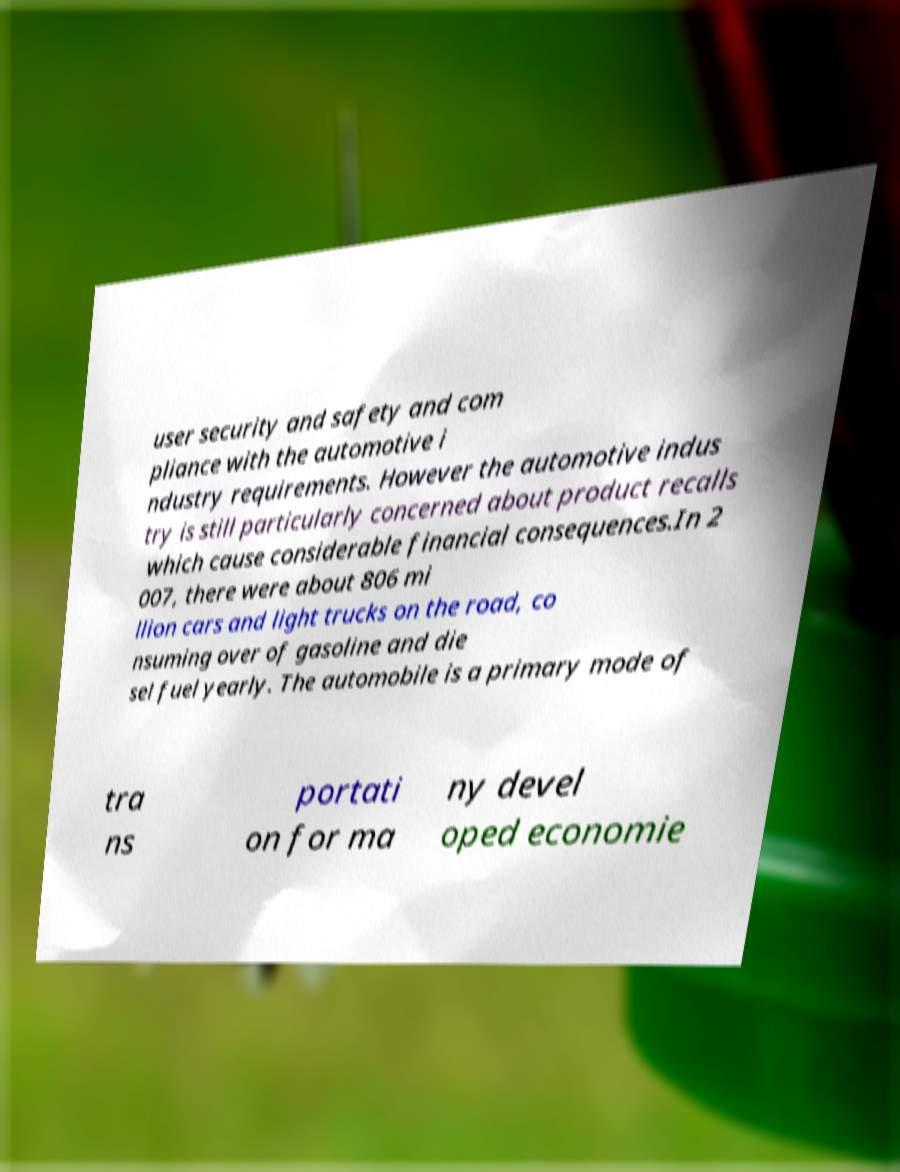Please identify and transcribe the text found in this image. user security and safety and com pliance with the automotive i ndustry requirements. However the automotive indus try is still particularly concerned about product recalls which cause considerable financial consequences.In 2 007, there were about 806 mi llion cars and light trucks on the road, co nsuming over of gasoline and die sel fuel yearly. The automobile is a primary mode of tra ns portati on for ma ny devel oped economie 